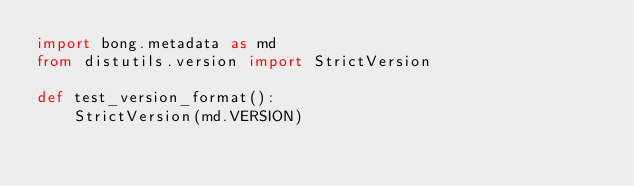<code> <loc_0><loc_0><loc_500><loc_500><_Python_>import bong.metadata as md
from distutils.version import StrictVersion

def test_version_format():
    StrictVersion(md.VERSION)

</code> 